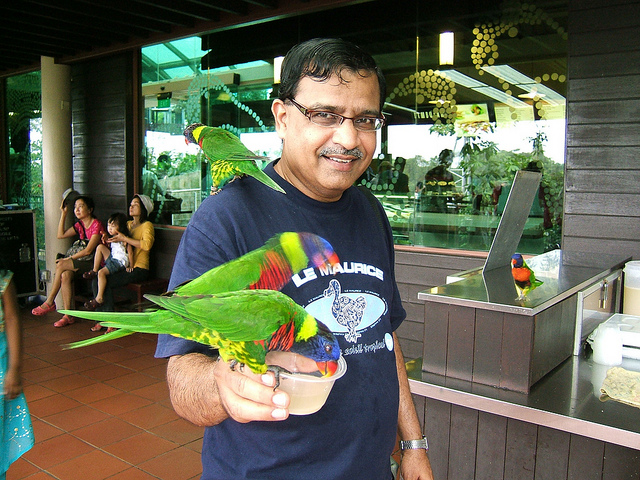Identify the text contained in this image. MAURICE 